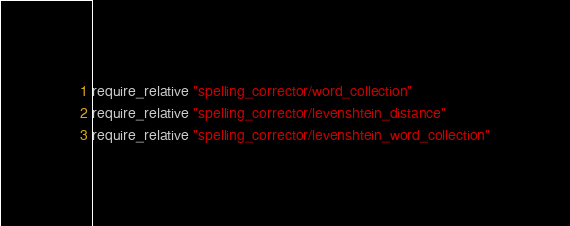<code> <loc_0><loc_0><loc_500><loc_500><_Ruby_>require_relative "spelling_corrector/word_collection"
require_relative "spelling_corrector/levenshtein_distance"
require_relative "spelling_corrector/levenshtein_word_collection"

</code> 